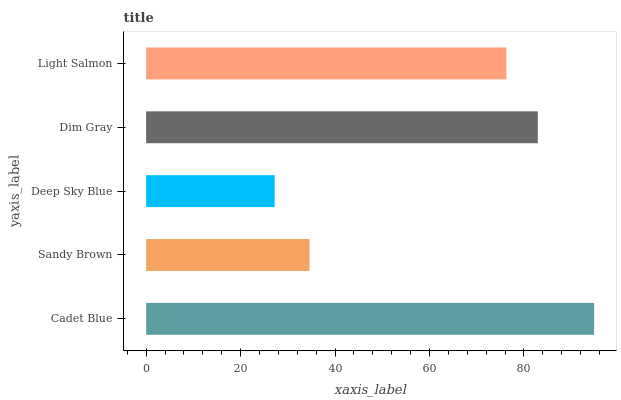Is Deep Sky Blue the minimum?
Answer yes or no. Yes. Is Cadet Blue the maximum?
Answer yes or no. Yes. Is Sandy Brown the minimum?
Answer yes or no. No. Is Sandy Brown the maximum?
Answer yes or no. No. Is Cadet Blue greater than Sandy Brown?
Answer yes or no. Yes. Is Sandy Brown less than Cadet Blue?
Answer yes or no. Yes. Is Sandy Brown greater than Cadet Blue?
Answer yes or no. No. Is Cadet Blue less than Sandy Brown?
Answer yes or no. No. Is Light Salmon the high median?
Answer yes or no. Yes. Is Light Salmon the low median?
Answer yes or no. Yes. Is Dim Gray the high median?
Answer yes or no. No. Is Dim Gray the low median?
Answer yes or no. No. 